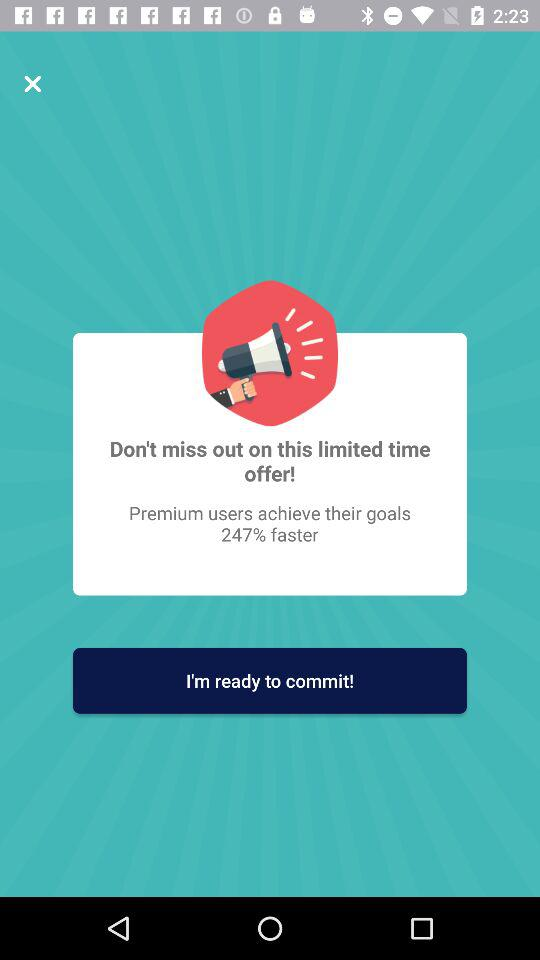What is the name of the application?
When the provided information is insufficient, respond with <no answer>. <no answer> 